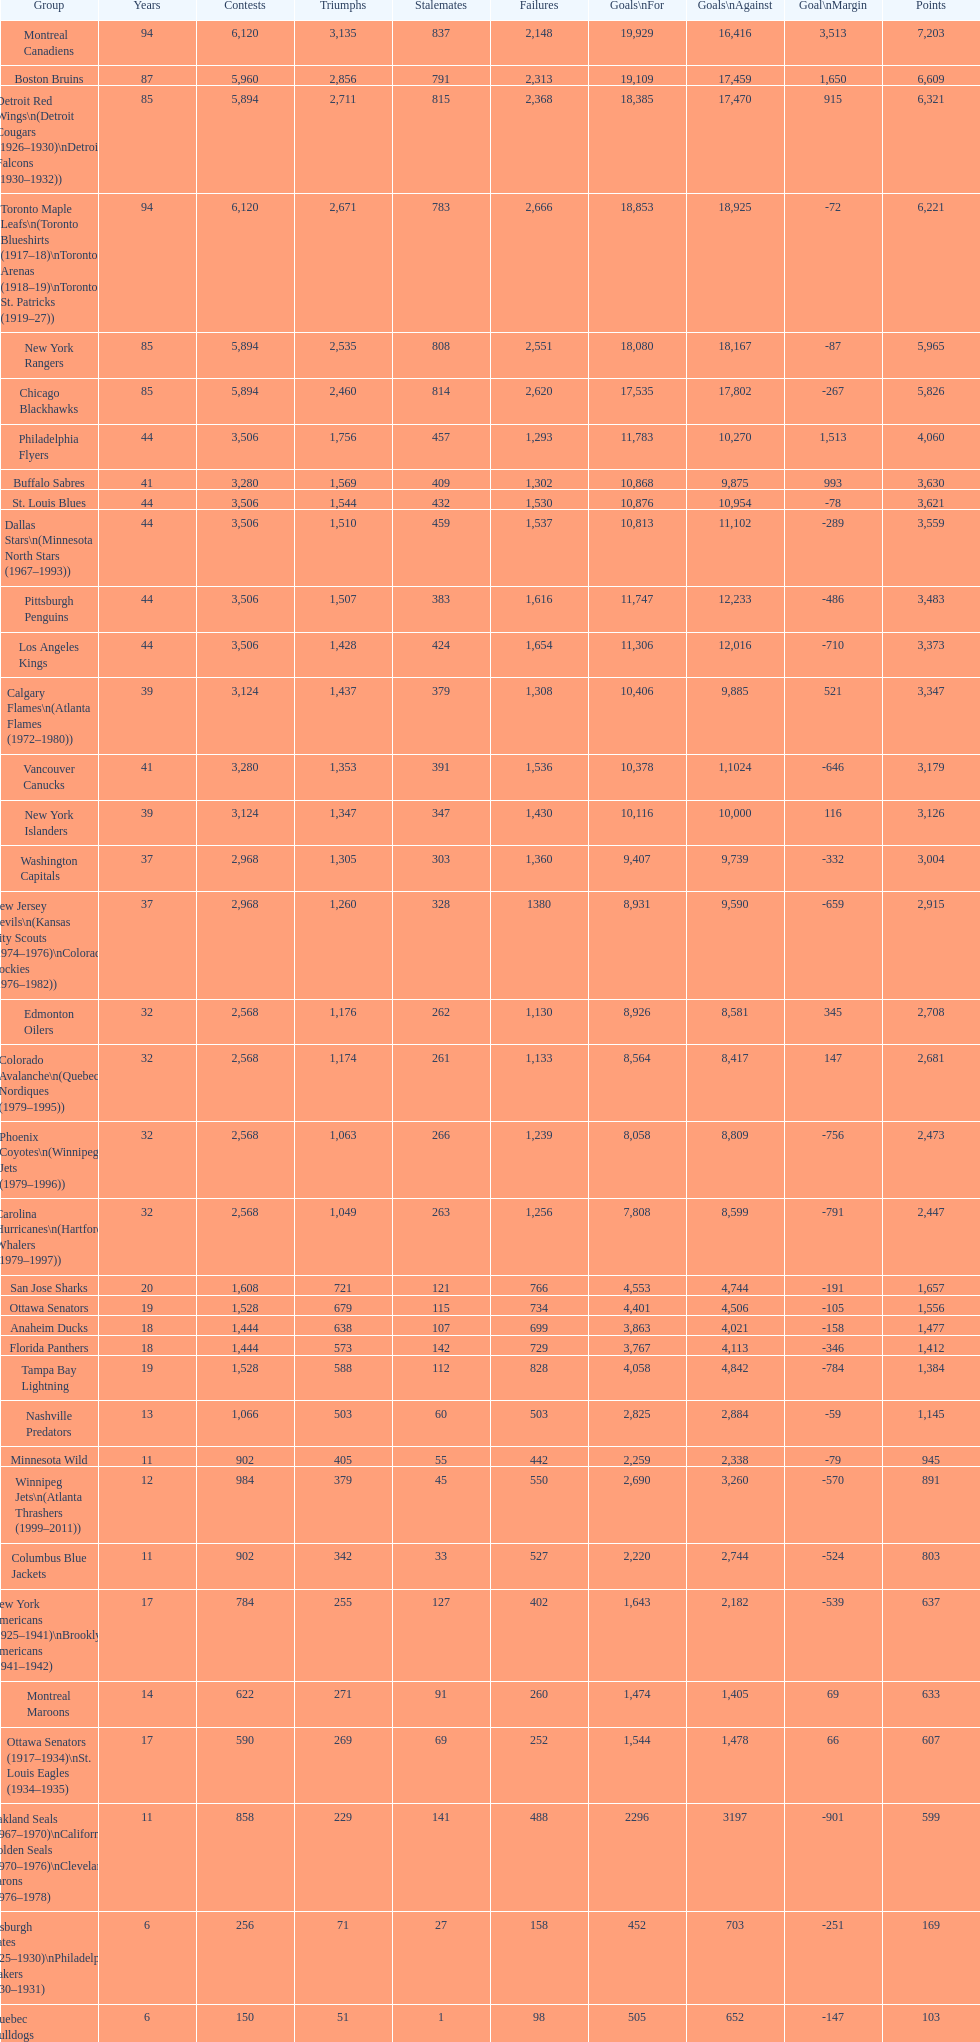What is the number of games that the vancouver canucks have won up to this point? 1,353. Write the full table. {'header': ['Group', 'Years', 'Contests', 'Triumphs', 'Stalemates', 'Failures', 'Goals\\nFor', 'Goals\\nAgainst', 'Goal\\nMargin', 'Points'], 'rows': [['Montreal Canadiens', '94', '6,120', '3,135', '837', '2,148', '19,929', '16,416', '3,513', '7,203'], ['Boston Bruins', '87', '5,960', '2,856', '791', '2,313', '19,109', '17,459', '1,650', '6,609'], ['Detroit Red Wings\\n(Detroit Cougars (1926–1930)\\nDetroit Falcons (1930–1932))', '85', '5,894', '2,711', '815', '2,368', '18,385', '17,470', '915', '6,321'], ['Toronto Maple Leafs\\n(Toronto Blueshirts (1917–18)\\nToronto Arenas (1918–19)\\nToronto St. Patricks (1919–27))', '94', '6,120', '2,671', '783', '2,666', '18,853', '18,925', '-72', '6,221'], ['New York Rangers', '85', '5,894', '2,535', '808', '2,551', '18,080', '18,167', '-87', '5,965'], ['Chicago Blackhawks', '85', '5,894', '2,460', '814', '2,620', '17,535', '17,802', '-267', '5,826'], ['Philadelphia Flyers', '44', '3,506', '1,756', '457', '1,293', '11,783', '10,270', '1,513', '4,060'], ['Buffalo Sabres', '41', '3,280', '1,569', '409', '1,302', '10,868', '9,875', '993', '3,630'], ['St. Louis Blues', '44', '3,506', '1,544', '432', '1,530', '10,876', '10,954', '-78', '3,621'], ['Dallas Stars\\n(Minnesota North Stars (1967–1993))', '44', '3,506', '1,510', '459', '1,537', '10,813', '11,102', '-289', '3,559'], ['Pittsburgh Penguins', '44', '3,506', '1,507', '383', '1,616', '11,747', '12,233', '-486', '3,483'], ['Los Angeles Kings', '44', '3,506', '1,428', '424', '1,654', '11,306', '12,016', '-710', '3,373'], ['Calgary Flames\\n(Atlanta Flames (1972–1980))', '39', '3,124', '1,437', '379', '1,308', '10,406', '9,885', '521', '3,347'], ['Vancouver Canucks', '41', '3,280', '1,353', '391', '1,536', '10,378', '1,1024', '-646', '3,179'], ['New York Islanders', '39', '3,124', '1,347', '347', '1,430', '10,116', '10,000', '116', '3,126'], ['Washington Capitals', '37', '2,968', '1,305', '303', '1,360', '9,407', '9,739', '-332', '3,004'], ['New Jersey Devils\\n(Kansas City Scouts (1974–1976)\\nColorado Rockies (1976–1982))', '37', '2,968', '1,260', '328', '1380', '8,931', '9,590', '-659', '2,915'], ['Edmonton Oilers', '32', '2,568', '1,176', '262', '1,130', '8,926', '8,581', '345', '2,708'], ['Colorado Avalanche\\n(Quebec Nordiques (1979–1995))', '32', '2,568', '1,174', '261', '1,133', '8,564', '8,417', '147', '2,681'], ['Phoenix Coyotes\\n(Winnipeg Jets (1979–1996))', '32', '2,568', '1,063', '266', '1,239', '8,058', '8,809', '-756', '2,473'], ['Carolina Hurricanes\\n(Hartford Whalers (1979–1997))', '32', '2,568', '1,049', '263', '1,256', '7,808', '8,599', '-791', '2,447'], ['San Jose Sharks', '20', '1,608', '721', '121', '766', '4,553', '4,744', '-191', '1,657'], ['Ottawa Senators', '19', '1,528', '679', '115', '734', '4,401', '4,506', '-105', '1,556'], ['Anaheim Ducks', '18', '1,444', '638', '107', '699', '3,863', '4,021', '-158', '1,477'], ['Florida Panthers', '18', '1,444', '573', '142', '729', '3,767', '4,113', '-346', '1,412'], ['Tampa Bay Lightning', '19', '1,528', '588', '112', '828', '4,058', '4,842', '-784', '1,384'], ['Nashville Predators', '13', '1,066', '503', '60', '503', '2,825', '2,884', '-59', '1,145'], ['Minnesota Wild', '11', '902', '405', '55', '442', '2,259', '2,338', '-79', '945'], ['Winnipeg Jets\\n(Atlanta Thrashers (1999–2011))', '12', '984', '379', '45', '550', '2,690', '3,260', '-570', '891'], ['Columbus Blue Jackets', '11', '902', '342', '33', '527', '2,220', '2,744', '-524', '803'], ['New York Americans (1925–1941)\\nBrooklyn Americans (1941–1942)', '17', '784', '255', '127', '402', '1,643', '2,182', '-539', '637'], ['Montreal Maroons', '14', '622', '271', '91', '260', '1,474', '1,405', '69', '633'], ['Ottawa Senators (1917–1934)\\nSt. Louis Eagles (1934–1935)', '17', '590', '269', '69', '252', '1,544', '1,478', '66', '607'], ['Oakland Seals (1967–1970)\\nCalifornia Golden Seals (1970–1976)\\nCleveland Barons (1976–1978)', '11', '858', '229', '141', '488', '2296', '3197', '-901', '599'], ['Pittsburgh Pirates (1925–1930)\\nPhiladelphia Quakers (1930–1931)', '6', '256', '71', '27', '158', '452', '703', '-251', '169'], ['Quebec Bulldogs (1919–1920)\\nHamilton Tigers (1920–1925)', '6', '150', '51', '1', '98', '505', '652', '-147', '103'], ['Montreal Wanderers', '1', '6', '1', '0', '5', '17', '35', '-18', '2']]} 